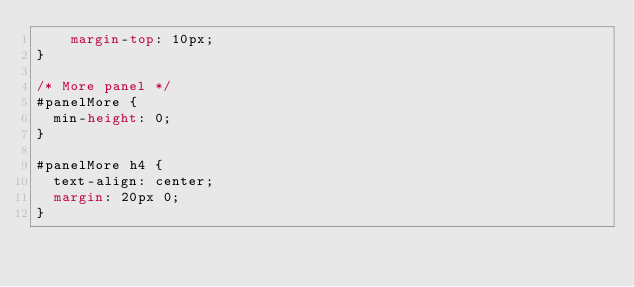Convert code to text. <code><loc_0><loc_0><loc_500><loc_500><_CSS_>    margin-top: 10px;
}

/* More panel */
#panelMore {
  min-height: 0;
}

#panelMore h4 {
  text-align: center;
  margin: 20px 0;
}</code> 